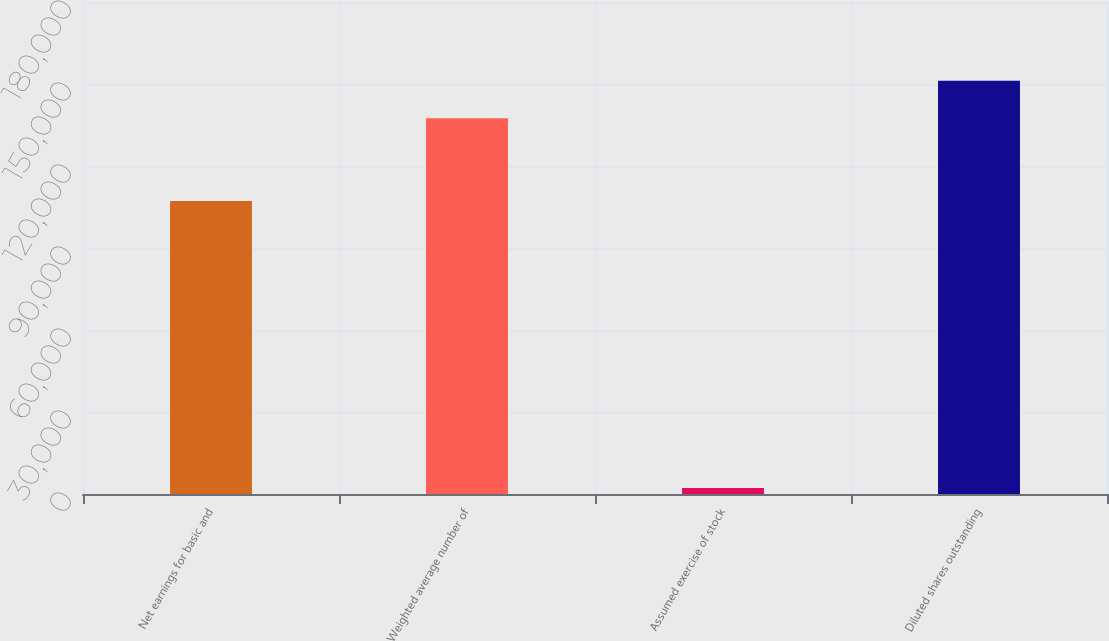<chart> <loc_0><loc_0><loc_500><loc_500><bar_chart><fcel>Net earnings for basic and<fcel>Weighted average number of<fcel>Assumed exercise of stock<fcel>Diluted shares outstanding<nl><fcel>107223<fcel>137456<fcel>2190<fcel>151202<nl></chart> 